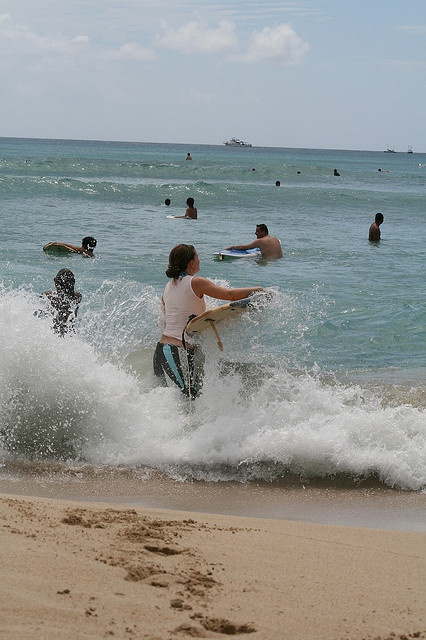Describe the objects in this image and their specific colors. I can see people in lightgray, darkgray, gray, and black tones, people in lightgray, black, gray, and darkgray tones, surfboard in lightgray, gray, darkgray, and black tones, people in lightgray, black, maroon, and gray tones, and people in lightgray, black, gray, maroon, and darkgray tones in this image. 